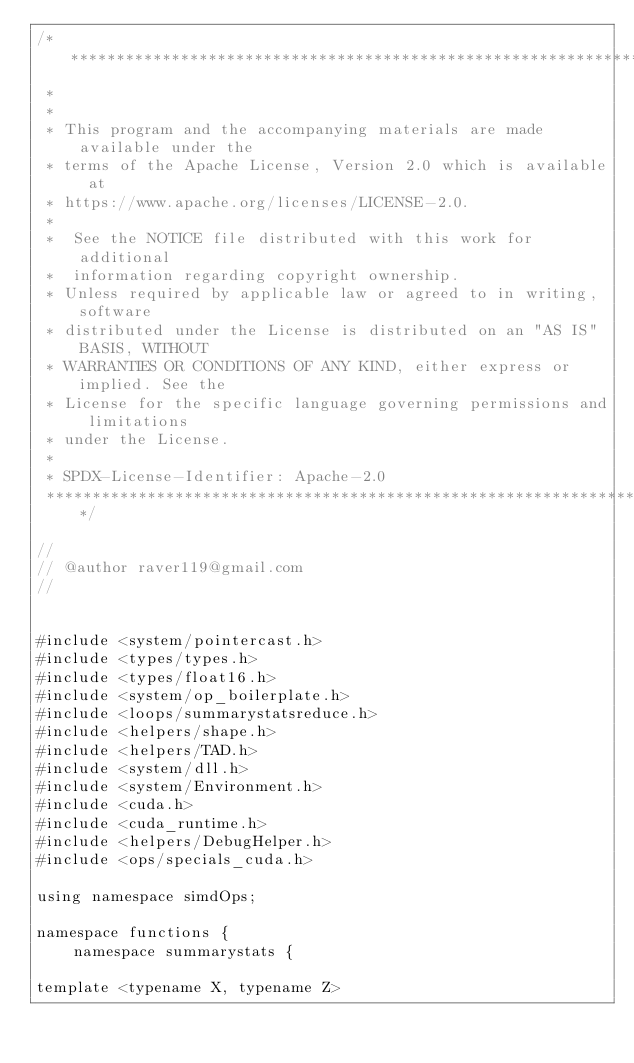Convert code to text. <code><loc_0><loc_0><loc_500><loc_500><_Cuda_>/* ******************************************************************************
 *
 *
 * This program and the accompanying materials are made available under the
 * terms of the Apache License, Version 2.0 which is available at
 * https://www.apache.org/licenses/LICENSE-2.0.
 *
 *  See the NOTICE file distributed with this work for additional
 *  information regarding copyright ownership.
 * Unless required by applicable law or agreed to in writing, software
 * distributed under the License is distributed on an "AS IS" BASIS, WITHOUT
 * WARRANTIES OR CONDITIONS OF ANY KIND, either express or implied. See the
 * License for the specific language governing permissions and limitations
 * under the License.
 *
 * SPDX-License-Identifier: Apache-2.0
 ******************************************************************************/

//
// @author raver119@gmail.com
//


#include <system/pointercast.h>
#include <types/types.h>
#include <types/float16.h>
#include <system/op_boilerplate.h>
#include <loops/summarystatsreduce.h>
#include <helpers/shape.h>
#include <helpers/TAD.h>
#include <system/dll.h>
#include <system/Environment.h>
#include <cuda.h>
#include <cuda_runtime.h>
#include <helpers/DebugHelper.h>
#include <ops/specials_cuda.h>

using namespace simdOps;

namespace functions {
    namespace summarystats {

template <typename X, typename Z></code> 